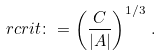Convert formula to latex. <formula><loc_0><loc_0><loc_500><loc_500>\ r c r i t \colon = \left ( \frac { C } { | A | } \right ) ^ { 1 / 3 } \, .</formula> 